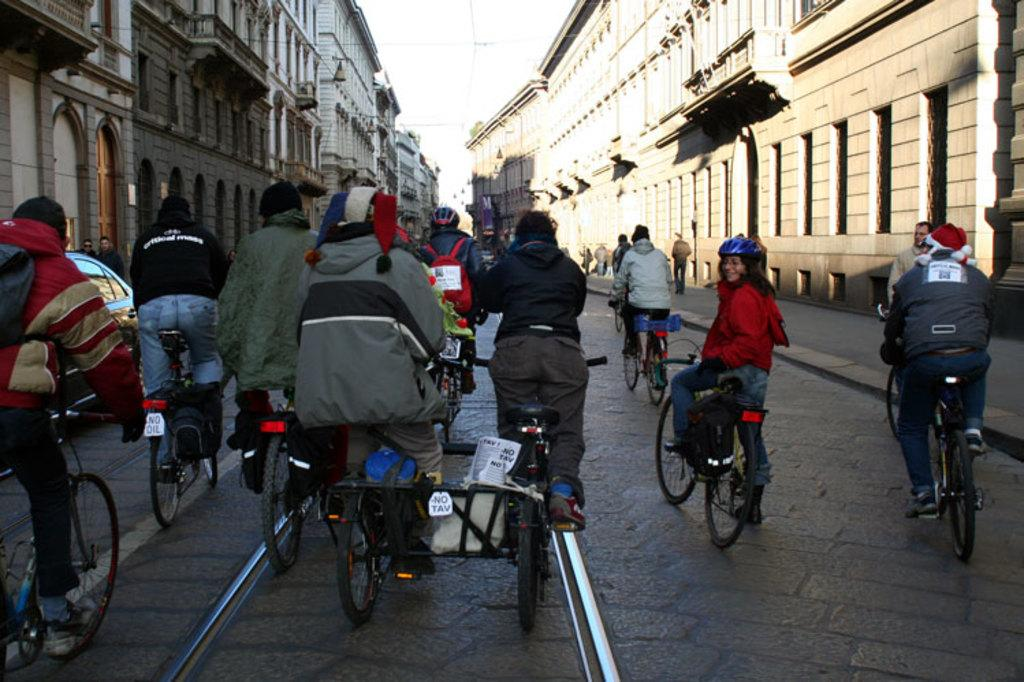What can be seen in the background of the image? There is a sky in the image. What structures are visible in the image? There are buildings in the image. What activity can be observed on the road in the image? There are people riding bicycles on the road in the image. How many rats can be seen climbing the buildings in the image? There are no rats present in the image; it only features buildings, a sky, and people riding bicycles. What detail can be observed on the bicycles that the people are riding? The provided facts do not mention any specific details about the bicycles, so we cannot answer this question definitively. 